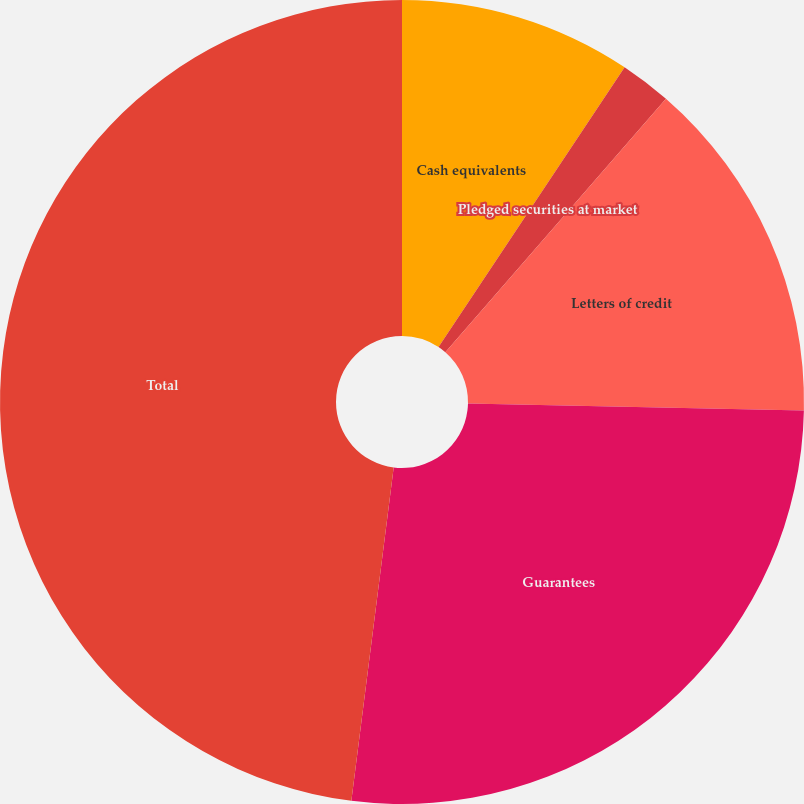Convert chart to OTSL. <chart><loc_0><loc_0><loc_500><loc_500><pie_chart><fcel>Cash equivalents<fcel>Pledged securities at market<fcel>Letters of credit<fcel>Guarantees<fcel>Total<nl><fcel>9.34%<fcel>2.06%<fcel>13.94%<fcel>26.67%<fcel>47.99%<nl></chart> 